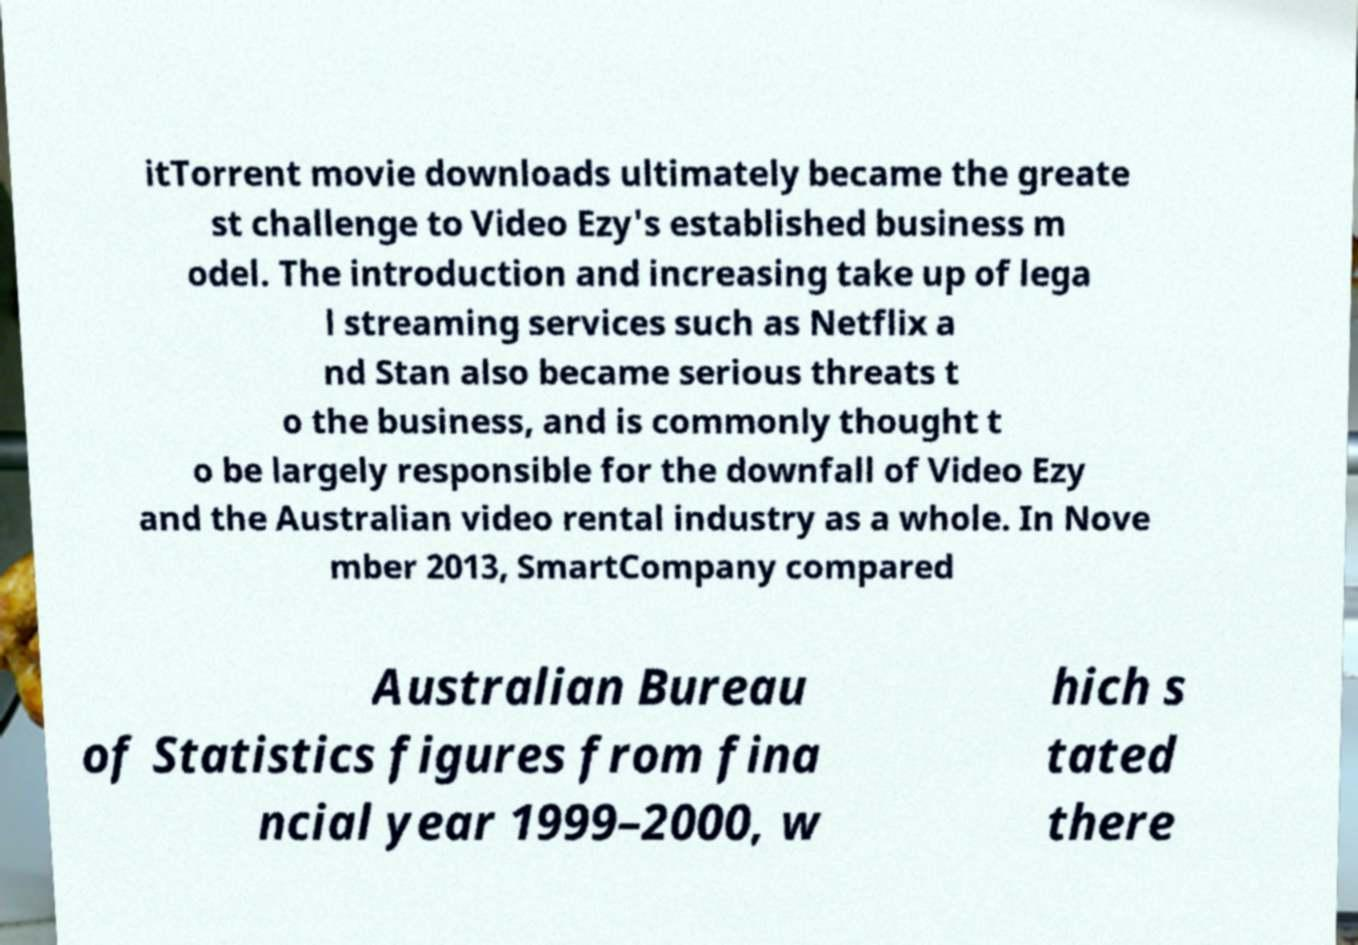Can you read and provide the text displayed in the image?This photo seems to have some interesting text. Can you extract and type it out for me? itTorrent movie downloads ultimately became the greate st challenge to Video Ezy's established business m odel. The introduction and increasing take up of lega l streaming services such as Netflix a nd Stan also became serious threats t o the business, and is commonly thought t o be largely responsible for the downfall of Video Ezy and the Australian video rental industry as a whole. In Nove mber 2013, SmartCompany compared Australian Bureau of Statistics figures from fina ncial year 1999–2000, w hich s tated there 